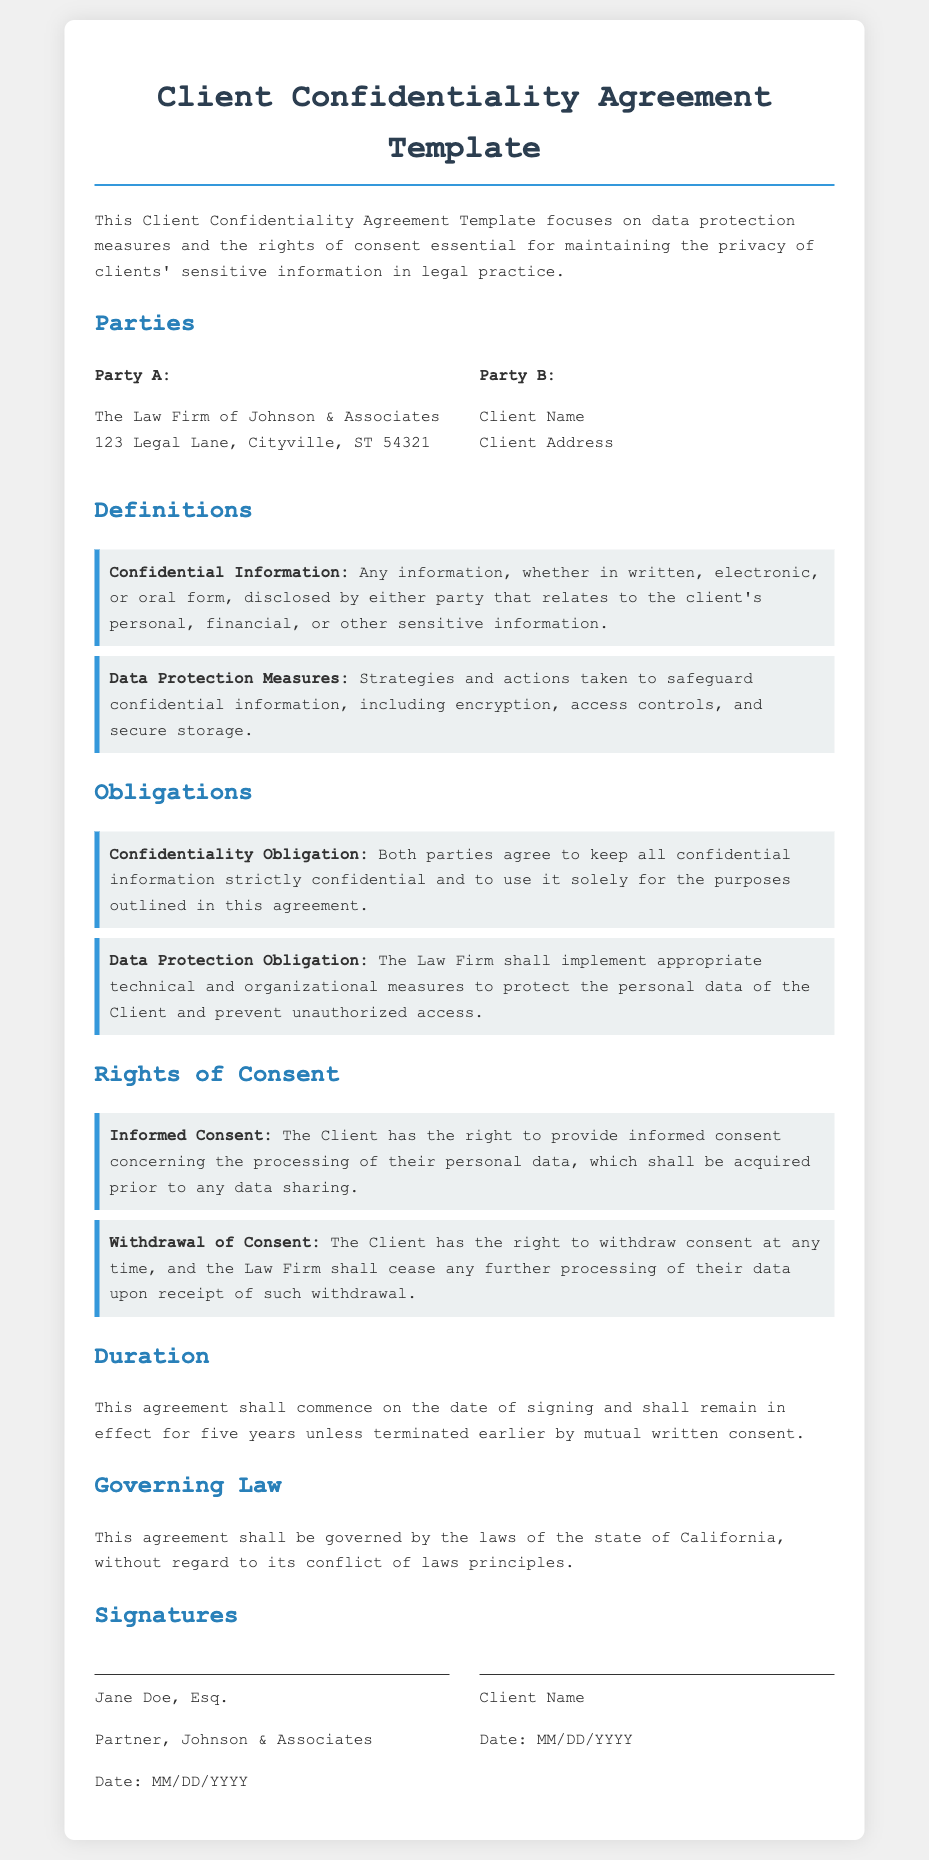What is the name of Party A? Party A is identified as "The Law Firm of Johnson & Associates" in the document.
Answer: The Law Firm of Johnson & Associates What is the duration of the agreement? The document specifies that the agreement shall remain in effect for five years unless terminated earlier.
Answer: five years What are Data Protection Measures? The document defines Data Protection Measures as "strategies and actions taken to safeguard confidential information."
Answer: strategies and actions taken to safeguard confidential information What right does the Client have regarding consent? The document states that the Client has the right to provide informed consent concerning the processing of their personal data.
Answer: informed consent What must the Law Firm implement to protect personal data? The document indicates that the Law Firm shall implement "appropriate technical and organizational measures" to protect the personal data of the Client.
Answer: appropriate technical and organizational measures What is required for the Client to withdraw consent? The document states that the Law Firm shall cease processing of data upon receipt of withdrawal, which is indicated by "withdraw consent at any time."
Answer: withdraw consent at any time Under which state's law is the agreement governed? The governing law section specifies that this agreement shall be governed by the laws of the state of California.
Answer: California Who is the signatory for Party A? The document lists "Jane Doe, Esq." as the signatory for Party A.
Answer: Jane Doe, Esq What type of information is considered "Confidential Information"? The document defines Confidential Information as "any information... that relates to the client's personal, financial, or other sensitive information."
Answer: any information... that relates to the client's personal, financial, or other sensitive information 